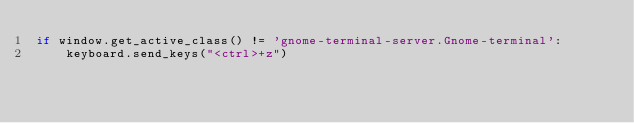Convert code to text. <code><loc_0><loc_0><loc_500><loc_500><_Python_>if window.get_active_class() != 'gnome-terminal-server.Gnome-terminal':
    keyboard.send_keys("<ctrl>+z")
</code> 